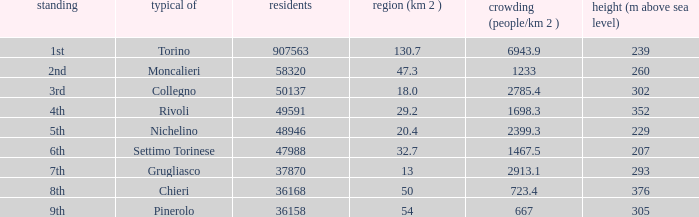How many population numbers are provided for settimo torinese? 1.0. 